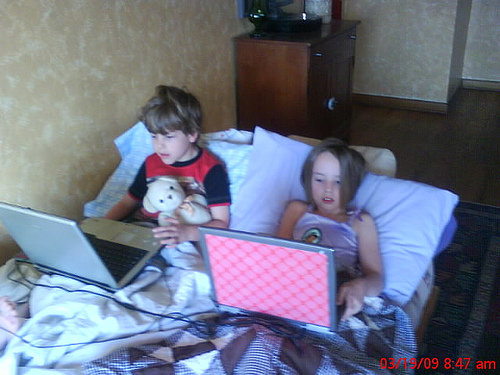Identify the text contained in this image. 03719709 8:47 am 